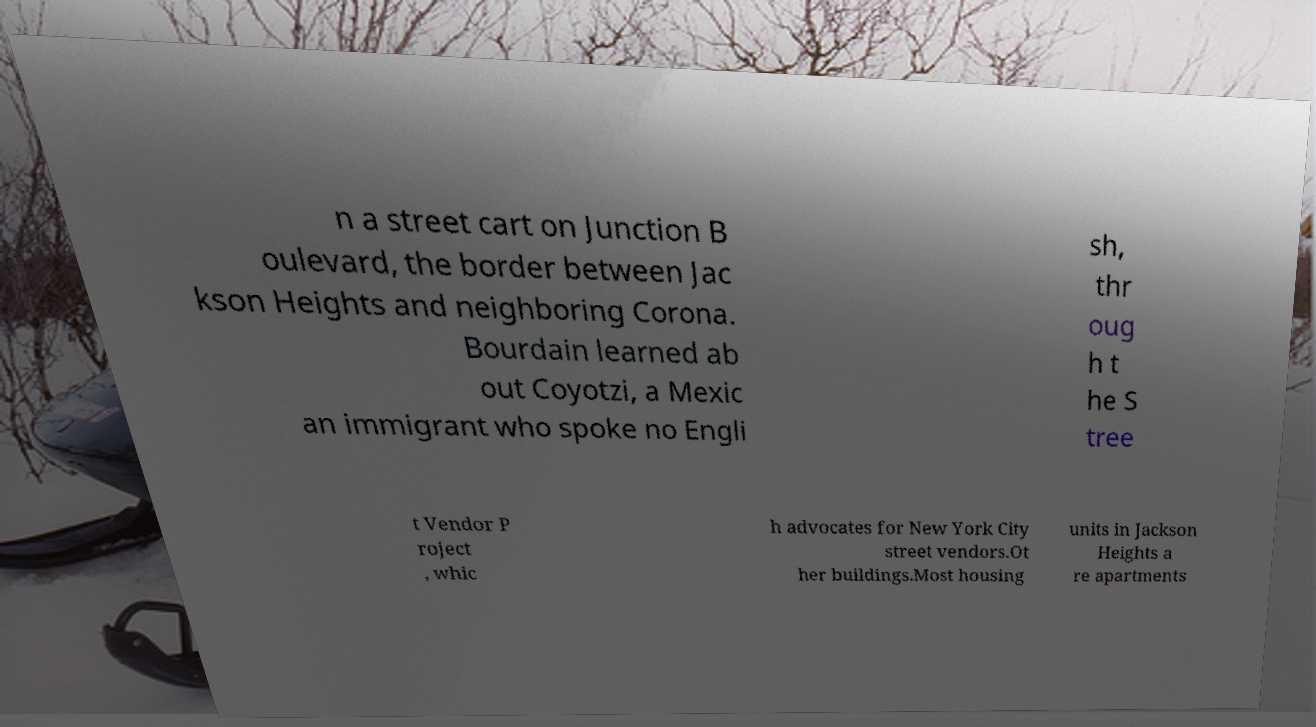Could you extract and type out the text from this image? n a street cart on Junction B oulevard, the border between Jac kson Heights and neighboring Corona. Bourdain learned ab out Coyotzi, a Mexic an immigrant who spoke no Engli sh, thr oug h t he S tree t Vendor P roject , whic h advocates for New York City street vendors.Ot her buildings.Most housing units in Jackson Heights a re apartments 